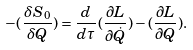Convert formula to latex. <formula><loc_0><loc_0><loc_500><loc_500>- ( \frac { \delta S _ { 0 } } { \delta Q } ) = \frac { d } { d \tau } ( \frac { \partial L } { \partial \dot { Q } } ) - ( \frac { \partial L } { \partial Q } ) .</formula> 